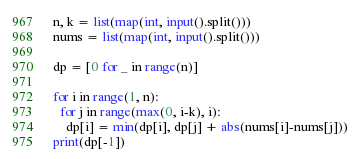Convert code to text. <code><loc_0><loc_0><loc_500><loc_500><_Python_>n, k = list(map(int, input().split()))
nums = list(map(int, input().split()))

dp = [0 for _ in range(n)]

for i in range(1, n):
  for j in range(max(0, i-k), i):
    dp[i] = min(dp[i], dp[j] + abs(nums[i]-nums[j]))
print(dp[-1])</code> 